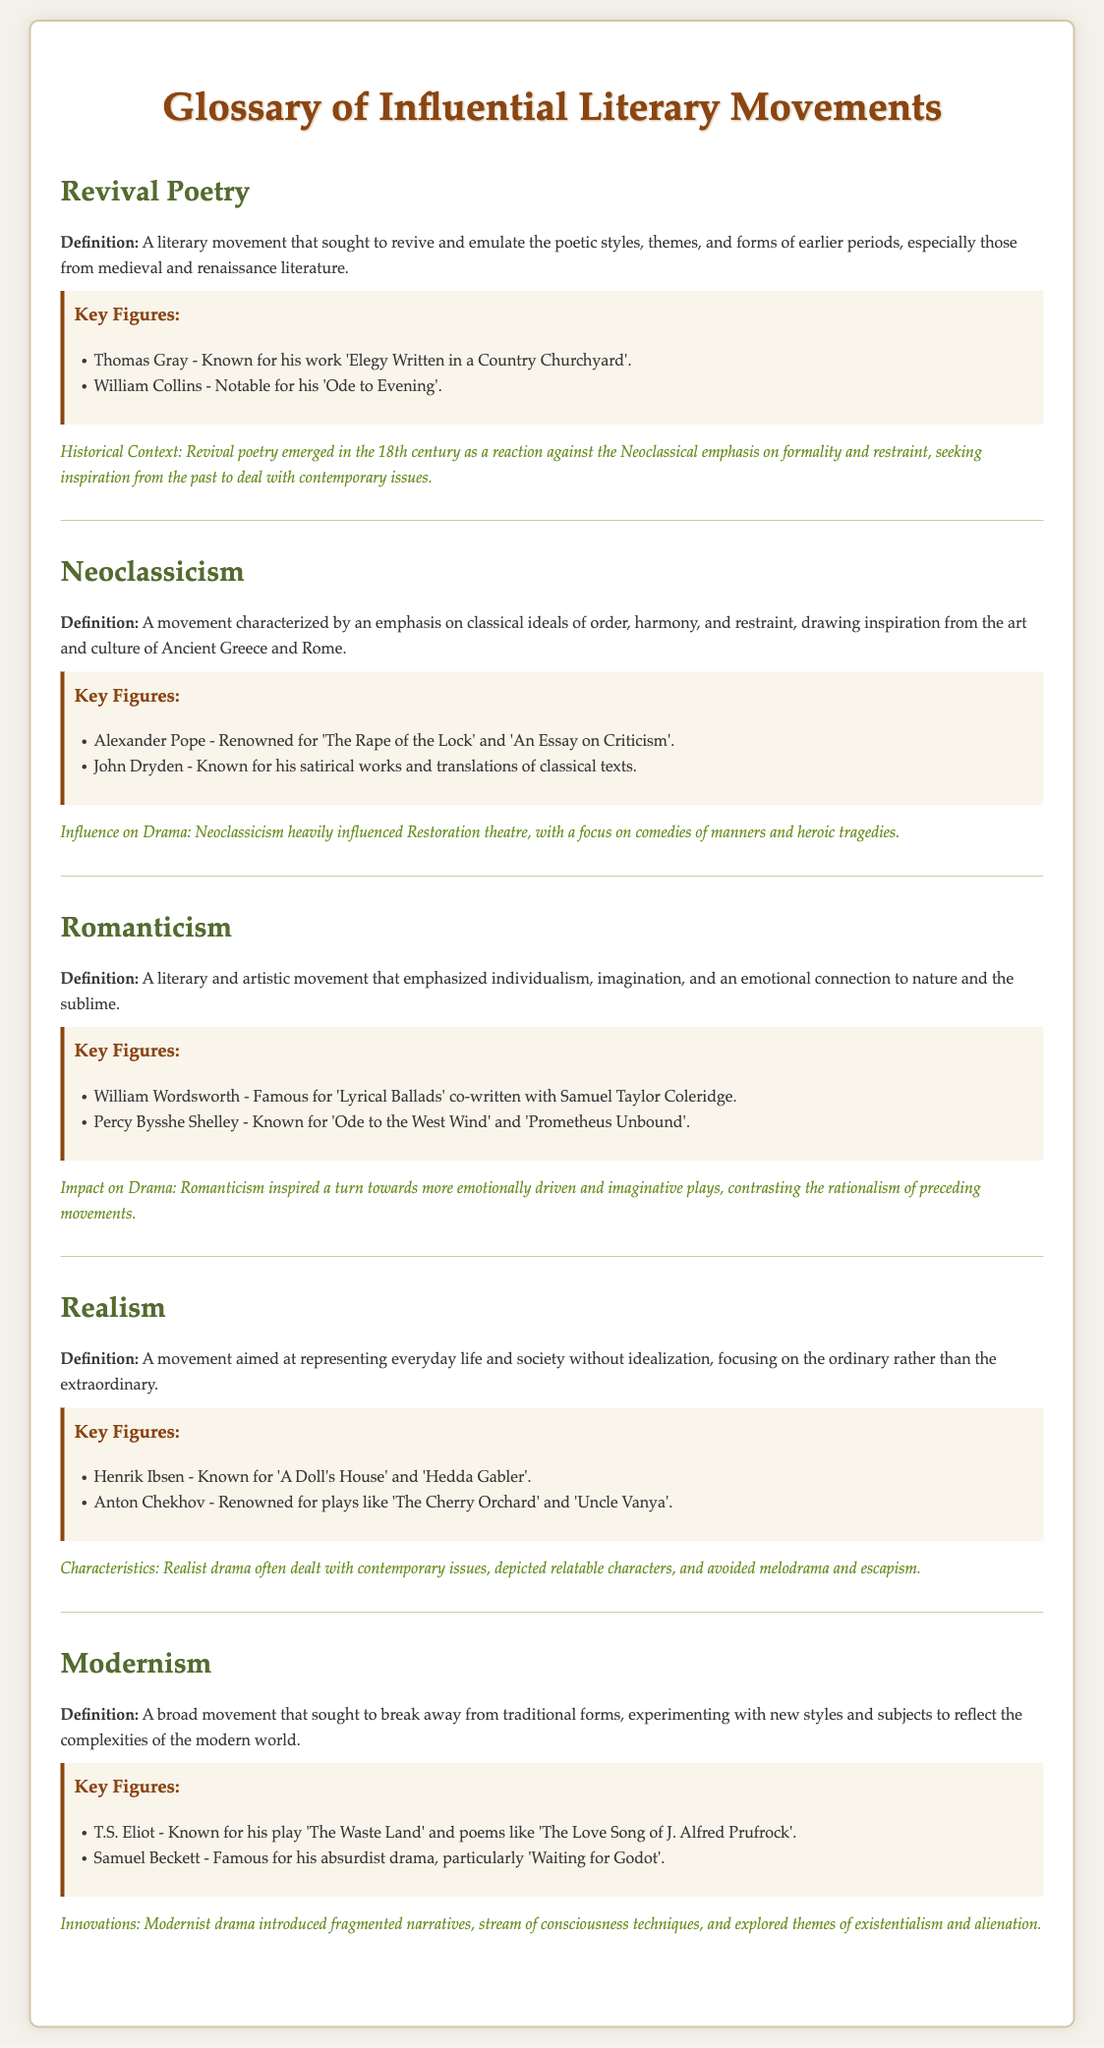What is Revival Poetry? Revival Poetry is defined as a literary movement that sought to revive and emulate the poetic styles, themes, and forms of earlier periods.
Answer: A literary movement that sought to revive and emulate the poetic styles, themes, and forms of earlier periods Who is a key figure in Neoclassicism? A key figure in Neoclassicism mentioned in the document is Alexander Pope.
Answer: Alexander Pope What play is Henrik Ibsen known for? Henrik Ibsen is known for the play 'A Doll's House'.
Answer: 'A Doll's House' What movement emphasized individualism and imagination? The literary movement that emphasized individualism and imagination is Romanticism.
Answer: Romanticism How did Modernism differ from previous movements? Modernism sought to break away from traditional forms and experiment with new styles and subjects.
Answer: Sought to break away from traditional forms What poem did William Wordsworth co-write? William Wordsworth co-wrote 'Lyrical Ballads' with Samuel Taylor Coleridge.
Answer: 'Lyrical Ballads' Which literary movement influenced Restoration theatre? The movement that influenced Restoration theatre was Neoclassicism.
Answer: Neoclassicism What was a characteristic of Realism? A characteristic of Realism is its focus on representing everyday life without idealization.
Answer: Focus on representing everyday life without idealization Who is known for the play 'Waiting for Godot'? Samuel Beckett is known for the play 'Waiting for Godot'.
Answer: Samuel Beckett 